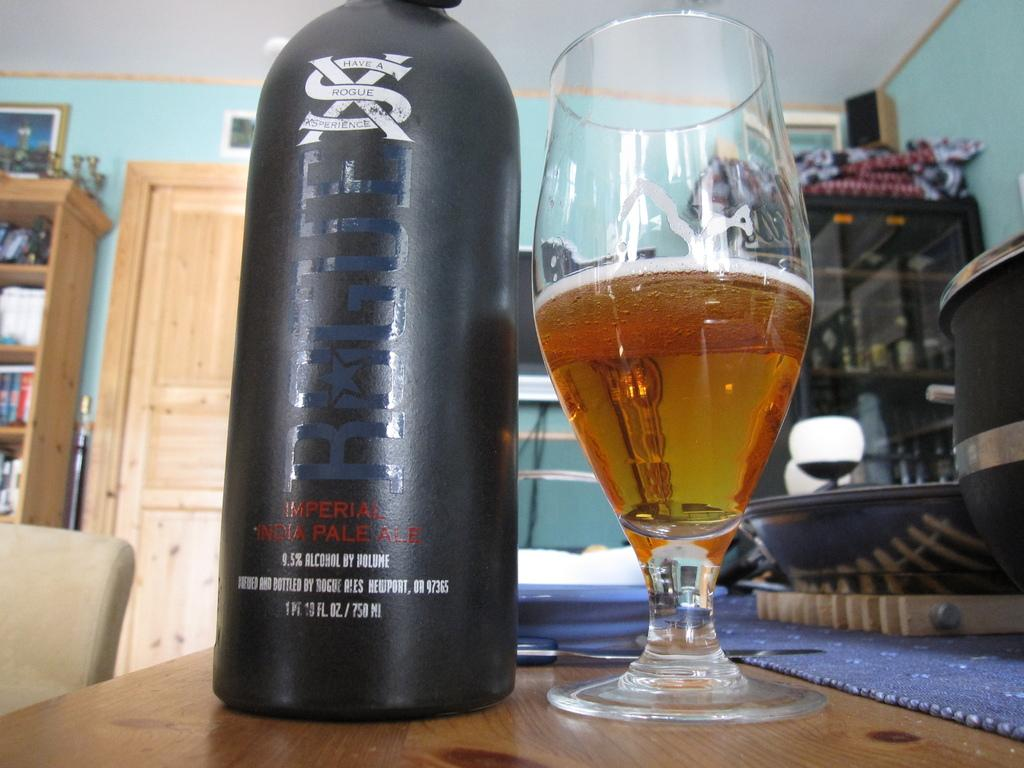Provide a one-sentence caption for the provided image. a bottle and glass of Rogue imperial pale ale. 